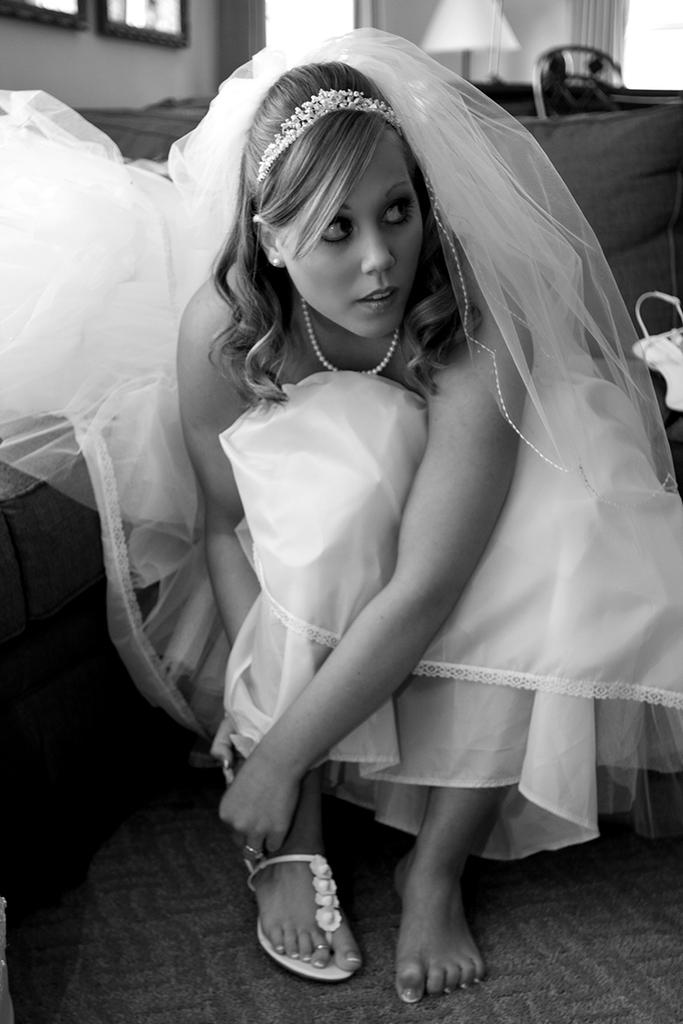What is the main subject of the image? There is a woman in the image. What is the woman doing in the image? The woman is in a squat position on the floor. What can be seen in the background of the image? There is a bed, a lamp, photo frames on a wall, and a curtain in the background of the image. What type of room might the image be taken in? The image is likely taken in a room, as there are furniture and decorations present. What type of throne is the woman sitting on in the image? There is no throne present in the image; the woman is in a squat position on the floor. How does the woman show respect to the match in the image? There is no match present in the image, and the woman is not shown demonstrating respect to any object or person. 